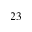<formula> <loc_0><loc_0><loc_500><loc_500>2 3</formula> 